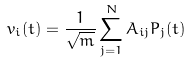Convert formula to latex. <formula><loc_0><loc_0><loc_500><loc_500>v _ { i } ( t ) = \frac { 1 } { \sqrt { m } } \sum _ { j = 1 } ^ { N } A _ { i j } P _ { j } ( t )</formula> 